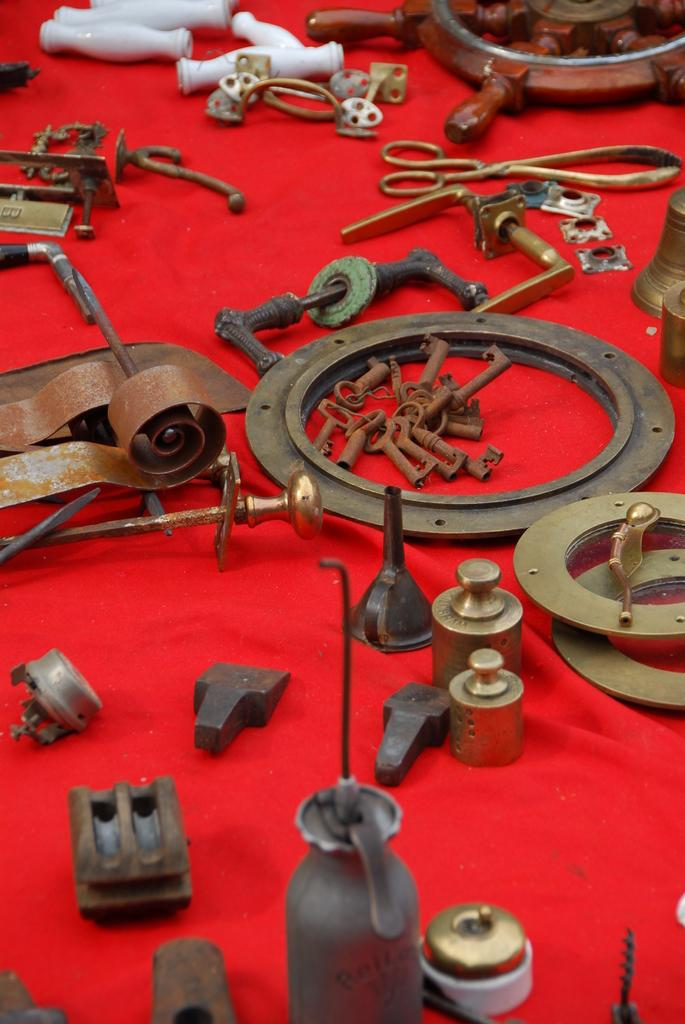What is there is a table in the image, what is on top of it? The table has a red carpet on it. What is placed on the red carpet? There are machinery tools on the red carpet. Can you describe the machinery tools? The machinery tools include screws and iron parts. Is there a representative from the seashore in the image? There is no reference to a representative or the seashore in the image. 